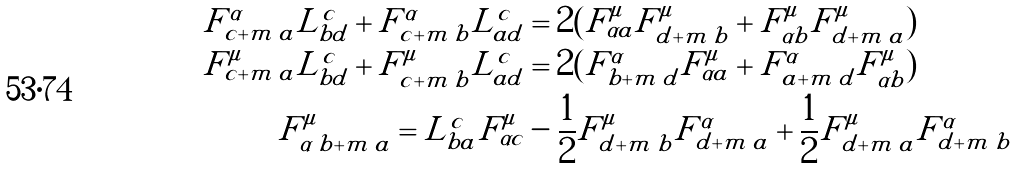<formula> <loc_0><loc_0><loc_500><loc_500>F ^ { \alpha } _ { c + m \, a } L ^ { c } _ { b d } + F ^ { \alpha } _ { c + m \, b } L ^ { c } _ { a d } & = 2 ( F ^ { \mu } _ { \alpha a } F ^ { \mu } _ { d + m \, b } + F ^ { \mu } _ { \alpha b } F ^ { \mu } _ { d + m \, a } ) \\ F ^ { \mu } _ { c + m \, a } L ^ { c } _ { b d } + F ^ { \mu } _ { c + m \, b } L ^ { c } _ { a d } & = 2 ( F ^ { \alpha } _ { b + m \, d } F ^ { \mu } _ { \alpha a } + F ^ { \alpha } _ { a + m \, d } F ^ { \mu } _ { \alpha b } ) \\ F ^ { \mu } _ { \alpha \, b + m \, a } = L ^ { c } _ { b a } F ^ { \mu } _ { \alpha c } & - \frac { 1 } { 2 } F ^ { \mu } _ { d + m \, b } F ^ { \alpha } _ { d + m \, a } + \frac { 1 } { 2 } F ^ { \mu } _ { d + m \, a } F ^ { \alpha } _ { d + m \, b }</formula> 